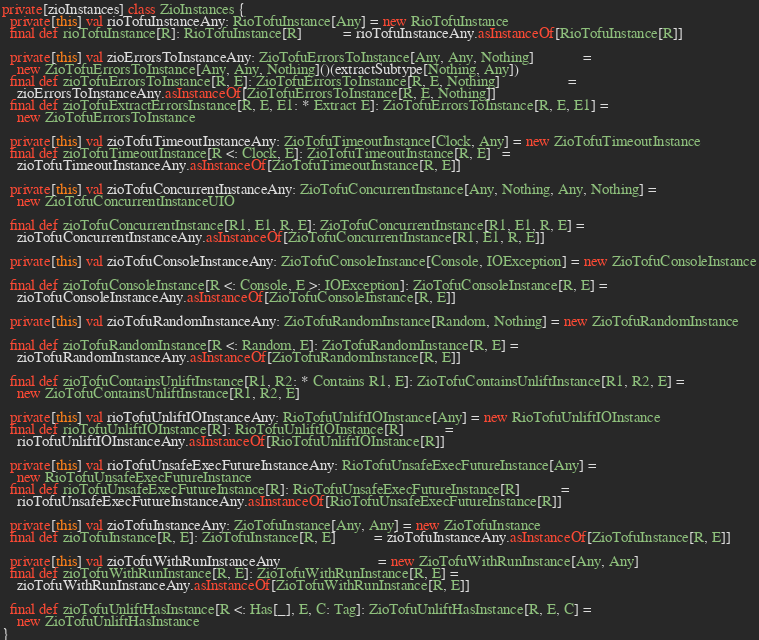Convert code to text. <code><loc_0><loc_0><loc_500><loc_500><_Scala_>private[zioInstances] class ZioInstances {
  private[this] val rioTofuInstanceAny: RioTofuInstance[Any] = new RioTofuInstance
  final def rioTofuInstance[R]: RioTofuInstance[R]           = rioTofuInstanceAny.asInstanceOf[RioTofuInstance[R]]

  private[this] val zioErrorsToInstanceAny: ZioTofuErrorsToInstance[Any, Any, Nothing]             =
    new ZioTofuErrorsToInstance[Any, Any, Nothing]()(extractSubtype[Nothing, Any])
  final def zioTofuErrorsToInstance[R, E]: ZioTofuErrorsToInstance[R, E, Nothing]                  =
    zioErrorsToInstanceAny.asInstanceOf[ZioTofuErrorsToInstance[R, E, Nothing]]
  final def zioTofuExtractErrorsInstance[R, E, E1: * Extract E]: ZioTofuErrorsToInstance[R, E, E1] =
    new ZioTofuErrorsToInstance

  private[this] val zioTofuTimeoutInstanceAny: ZioTofuTimeoutInstance[Clock, Any] = new ZioTofuTimeoutInstance
  final def zioTofuTimeoutInstance[R <: Clock, E]: ZioTofuTimeoutInstance[R, E]   =
    zioTofuTimeoutInstanceAny.asInstanceOf[ZioTofuTimeoutInstance[R, E]]

  private[this] val zioTofuConcurrentInstanceAny: ZioTofuConcurrentInstance[Any, Nothing, Any, Nothing] =
    new ZioTofuConcurrentInstanceUIO

  final def zioTofuConcurrentInstance[R1, E1, R, E]: ZioTofuConcurrentInstance[R1, E1, R, E] =
    zioTofuConcurrentInstanceAny.asInstanceOf[ZioTofuConcurrentInstance[R1, E1, R, E]]

  private[this] val zioTofuConsoleInstanceAny: ZioTofuConsoleInstance[Console, IOException] = new ZioTofuConsoleInstance

  final def zioTofuConsoleInstance[R <: Console, E >: IOException]: ZioTofuConsoleInstance[R, E] =
    zioTofuConsoleInstanceAny.asInstanceOf[ZioTofuConsoleInstance[R, E]]

  private[this] val zioTofuRandomInstanceAny: ZioTofuRandomInstance[Random, Nothing] = new ZioTofuRandomInstance

  final def zioTofuRandomInstance[R <: Random, E]: ZioTofuRandomInstance[R, E] =
    zioTofuRandomInstanceAny.asInstanceOf[ZioTofuRandomInstance[R, E]]

  final def zioTofuContainsUnliftInstance[R1, R2: * Contains R1, E]: ZioTofuContainsUnliftInstance[R1, R2, E] =
    new ZioTofuContainsUnliftInstance[R1, R2, E]

  private[this] val rioTofuUnliftIOInstanceAny: RioTofuUnliftIOInstance[Any] = new RioTofuUnliftIOInstance
  final def rioTofuUnliftIOInstance[R]: RioTofuUnliftIOInstance[R]           =
    rioTofuUnliftIOInstanceAny.asInstanceOf[RioTofuUnliftIOInstance[R]]

  private[this] val rioTofuUnsafeExecFutureInstanceAny: RioTofuUnsafeExecFutureInstance[Any] =
    new RioTofuUnsafeExecFutureInstance
  final def rioTofuUnsafeExecFutureInstance[R]: RioTofuUnsafeExecFutureInstance[R]           =
    rioTofuUnsafeExecFutureInstanceAny.asInstanceOf[RioTofuUnsafeExecFutureInstance[R]]

  private[this] val zioTofuInstanceAny: ZioTofuInstance[Any, Any] = new ZioTofuInstance
  final def zioTofuInstance[R, E]: ZioTofuInstance[R, E]          = zioTofuInstanceAny.asInstanceOf[ZioTofuInstance[R, E]]

  private[this] val zioTofuWithRunInstanceAny                          = new ZioTofuWithRunInstance[Any, Any]
  final def zioTofuWithRunInstance[R, E]: ZioTofuWithRunInstance[R, E] =
    zioTofuWithRunInstanceAny.asInstanceOf[ZioTofuWithRunInstance[R, E]]

  final def zioTofuUnliftHasInstance[R <: Has[_], E, C: Tag]: ZioTofuUnliftHasInstance[R, E, C] =
    new ZioTofuUnliftHasInstance
}
</code> 